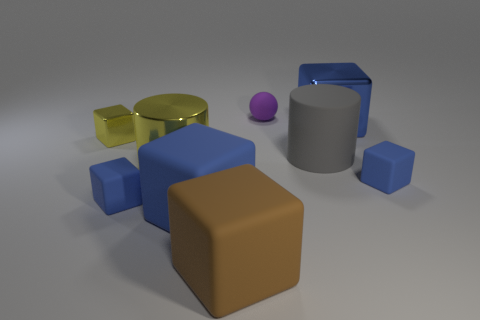There is another object that is the same shape as the gray matte thing; what is it made of?
Keep it short and to the point. Metal. Does the big brown rubber object have the same shape as the small blue matte thing that is right of the large yellow cylinder?
Offer a very short reply. Yes. There is a object that is behind the tiny yellow shiny cube and in front of the purple ball; how big is it?
Your answer should be very brief. Large. Are there any big blue objects that have the same material as the yellow block?
Provide a short and direct response. Yes. The metallic cube that is the same color as the large shiny cylinder is what size?
Offer a terse response. Small. What is the material of the big blue cube that is in front of the yellow thing that is in front of the gray object?
Give a very brief answer. Rubber. What number of large metallic blocks are the same color as the large matte cylinder?
Offer a terse response. 0. There is a cylinder that is made of the same material as the big brown object; what size is it?
Offer a terse response. Large. The big metal thing that is on the right side of the brown object has what shape?
Offer a terse response. Cube. What size is the brown thing that is the same shape as the blue shiny thing?
Make the answer very short. Large. 